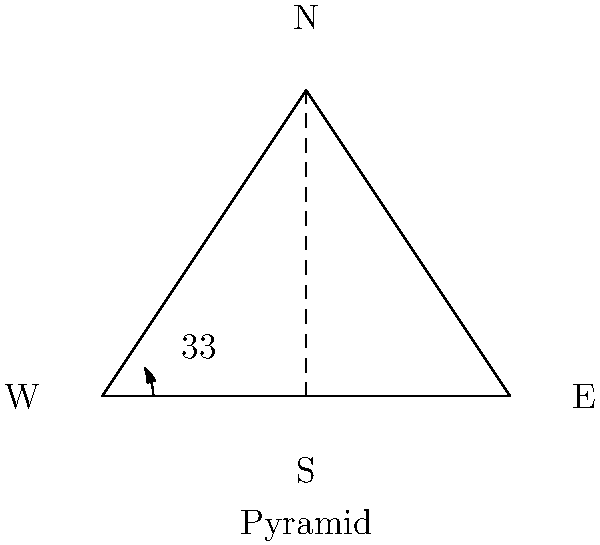Based on the architectural diagram provided, which celestial body might the ancient Egyptians have aligned this pyramid with, given its orientation of 33° east of true north? To answer this question, we need to consider several factors:

1. The diagram shows a pyramid with its base aligned 33° east of true north.

2. Ancient Egyptians were known to align their structures with celestial bodies for religious and astronomical purposes.

3. The orientation of 33° east of north is significant because it aligns closely with the rising point of certain stars.

4. One of the most important stars in ancient Egyptian astronomy was Sirius, also known as the "Dog Star."

5. Sirius was associated with the goddess Isis and played a crucial role in the Egyptian calendar.

6. Historical and archaeological evidence suggests that many Egyptian pyramids were oriented towards the rising point of Sirius on the eastern horizon.

7. The rising point of Sirius during the time of the Old Kingdom (when many pyramids were built) was approximately 28° to 30° east of true north.

8. The slight discrepancy between this and the 33° in our diagram can be accounted for by changes in the Earth's axial tilt over millennia and potential measurement inaccuracies in ancient times.

Given these factors, the most likely celestial body that this pyramid alignment corresponds to is Sirius.
Answer: Sirius 